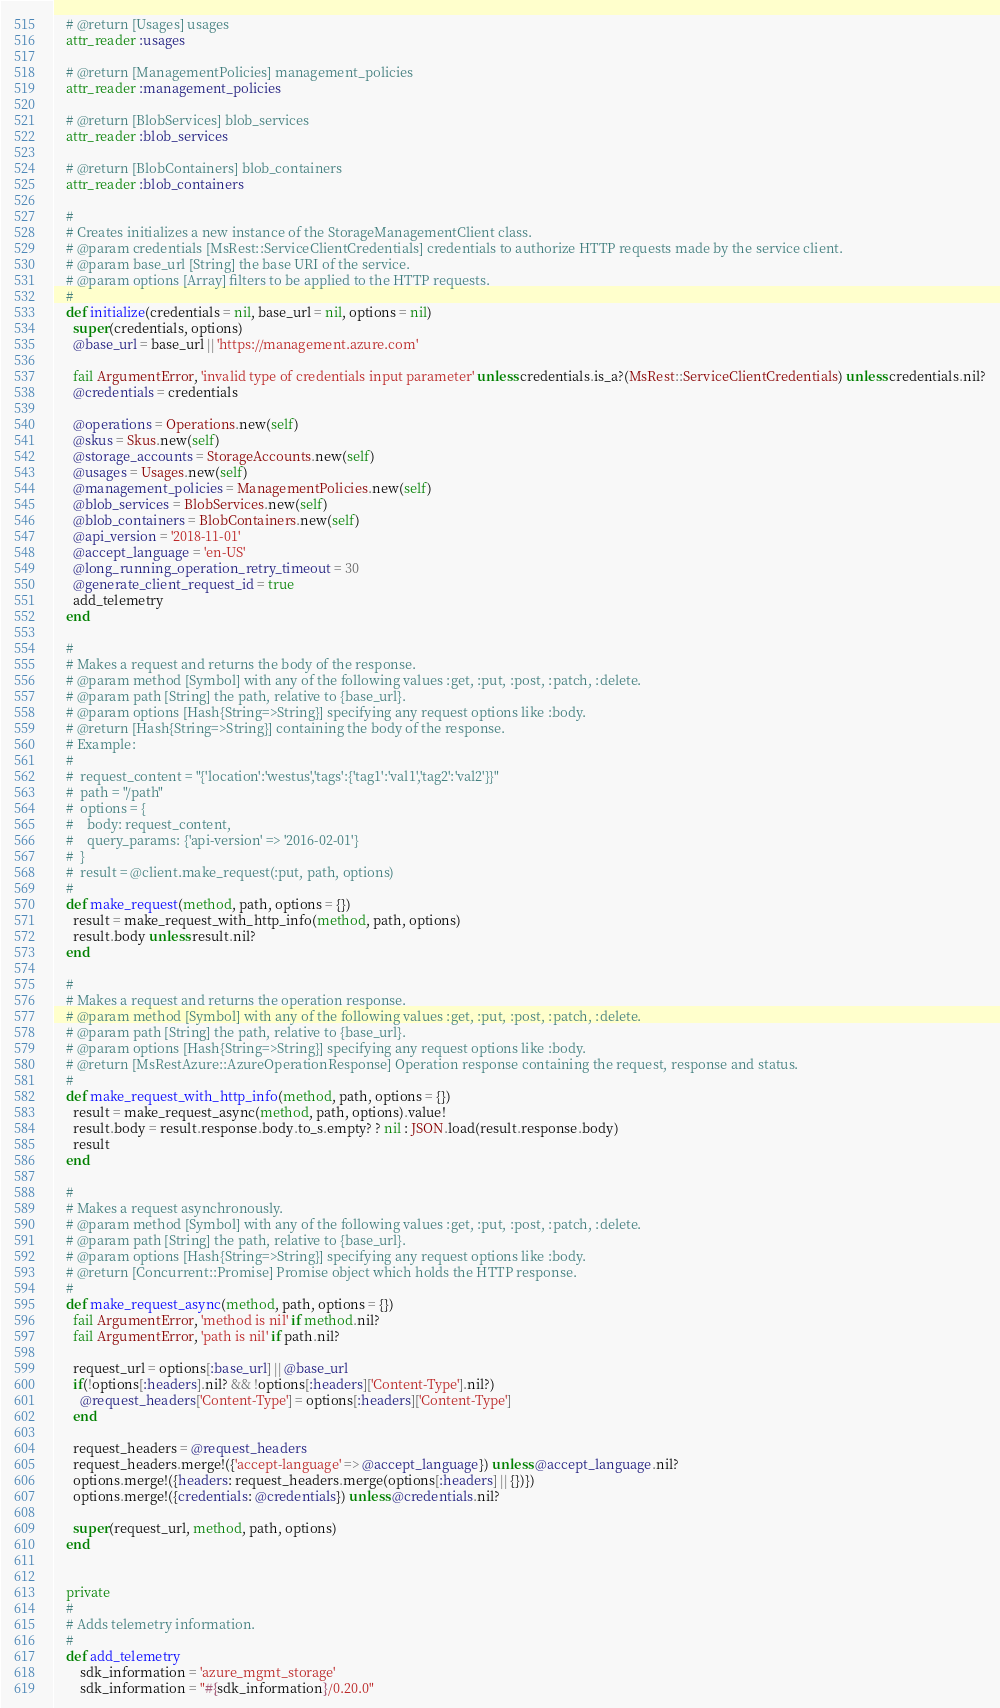<code> <loc_0><loc_0><loc_500><loc_500><_Ruby_>
    # @return [Usages] usages
    attr_reader :usages

    # @return [ManagementPolicies] management_policies
    attr_reader :management_policies

    # @return [BlobServices] blob_services
    attr_reader :blob_services

    # @return [BlobContainers] blob_containers
    attr_reader :blob_containers

    #
    # Creates initializes a new instance of the StorageManagementClient class.
    # @param credentials [MsRest::ServiceClientCredentials] credentials to authorize HTTP requests made by the service client.
    # @param base_url [String] the base URI of the service.
    # @param options [Array] filters to be applied to the HTTP requests.
    #
    def initialize(credentials = nil, base_url = nil, options = nil)
      super(credentials, options)
      @base_url = base_url || 'https://management.azure.com'

      fail ArgumentError, 'invalid type of credentials input parameter' unless credentials.is_a?(MsRest::ServiceClientCredentials) unless credentials.nil?
      @credentials = credentials

      @operations = Operations.new(self)
      @skus = Skus.new(self)
      @storage_accounts = StorageAccounts.new(self)
      @usages = Usages.new(self)
      @management_policies = ManagementPolicies.new(self)
      @blob_services = BlobServices.new(self)
      @blob_containers = BlobContainers.new(self)
      @api_version = '2018-11-01'
      @accept_language = 'en-US'
      @long_running_operation_retry_timeout = 30
      @generate_client_request_id = true
      add_telemetry
    end

    #
    # Makes a request and returns the body of the response.
    # @param method [Symbol] with any of the following values :get, :put, :post, :patch, :delete.
    # @param path [String] the path, relative to {base_url}.
    # @param options [Hash{String=>String}] specifying any request options like :body.
    # @return [Hash{String=>String}] containing the body of the response.
    # Example:
    #
    #  request_content = "{'location':'westus','tags':{'tag1':'val1','tag2':'val2'}}"
    #  path = "/path"
    #  options = {
    #    body: request_content,
    #    query_params: {'api-version' => '2016-02-01'}
    #  }
    #  result = @client.make_request(:put, path, options)
    #
    def make_request(method, path, options = {})
      result = make_request_with_http_info(method, path, options)
      result.body unless result.nil?
    end

    #
    # Makes a request and returns the operation response.
    # @param method [Symbol] with any of the following values :get, :put, :post, :patch, :delete.
    # @param path [String] the path, relative to {base_url}.
    # @param options [Hash{String=>String}] specifying any request options like :body.
    # @return [MsRestAzure::AzureOperationResponse] Operation response containing the request, response and status.
    #
    def make_request_with_http_info(method, path, options = {})
      result = make_request_async(method, path, options).value!
      result.body = result.response.body.to_s.empty? ? nil : JSON.load(result.response.body)
      result
    end

    #
    # Makes a request asynchronously.
    # @param method [Symbol] with any of the following values :get, :put, :post, :patch, :delete.
    # @param path [String] the path, relative to {base_url}.
    # @param options [Hash{String=>String}] specifying any request options like :body.
    # @return [Concurrent::Promise] Promise object which holds the HTTP response.
    #
    def make_request_async(method, path, options = {})
      fail ArgumentError, 'method is nil' if method.nil?
      fail ArgumentError, 'path is nil' if path.nil?

      request_url = options[:base_url] || @base_url
      if(!options[:headers].nil? && !options[:headers]['Content-Type'].nil?)
        @request_headers['Content-Type'] = options[:headers]['Content-Type']
      end

      request_headers = @request_headers
      request_headers.merge!({'accept-language' => @accept_language}) unless @accept_language.nil?
      options.merge!({headers: request_headers.merge(options[:headers] || {})})
      options.merge!({credentials: @credentials}) unless @credentials.nil?

      super(request_url, method, path, options)
    end


    private
    #
    # Adds telemetry information.
    #
    def add_telemetry
        sdk_information = 'azure_mgmt_storage'
        sdk_information = "#{sdk_information}/0.20.0"</code> 